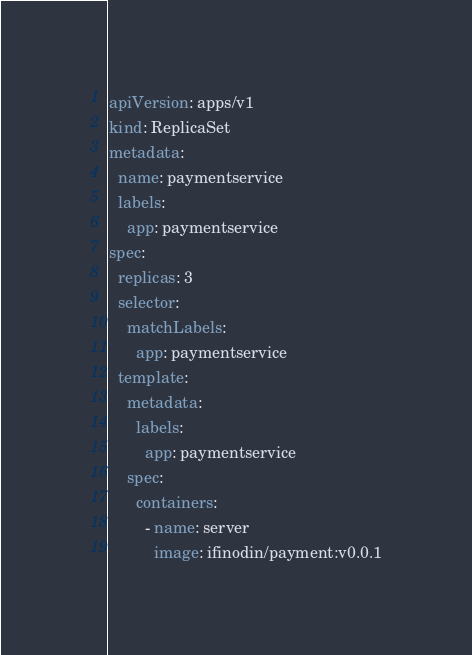Convert code to text. <code><loc_0><loc_0><loc_500><loc_500><_YAML_>apiVersion: apps/v1
kind: ReplicaSet
metadata:
  name: paymentservice
  labels:
    app: paymentservice
spec:
  replicas: 3
  selector:
    matchLabels:
      app: paymentservice
  template:
    metadata:
      labels:
        app: paymentservice
    spec:
      containers:
        - name: server
          image: ifinodin/payment:v0.0.1
</code> 